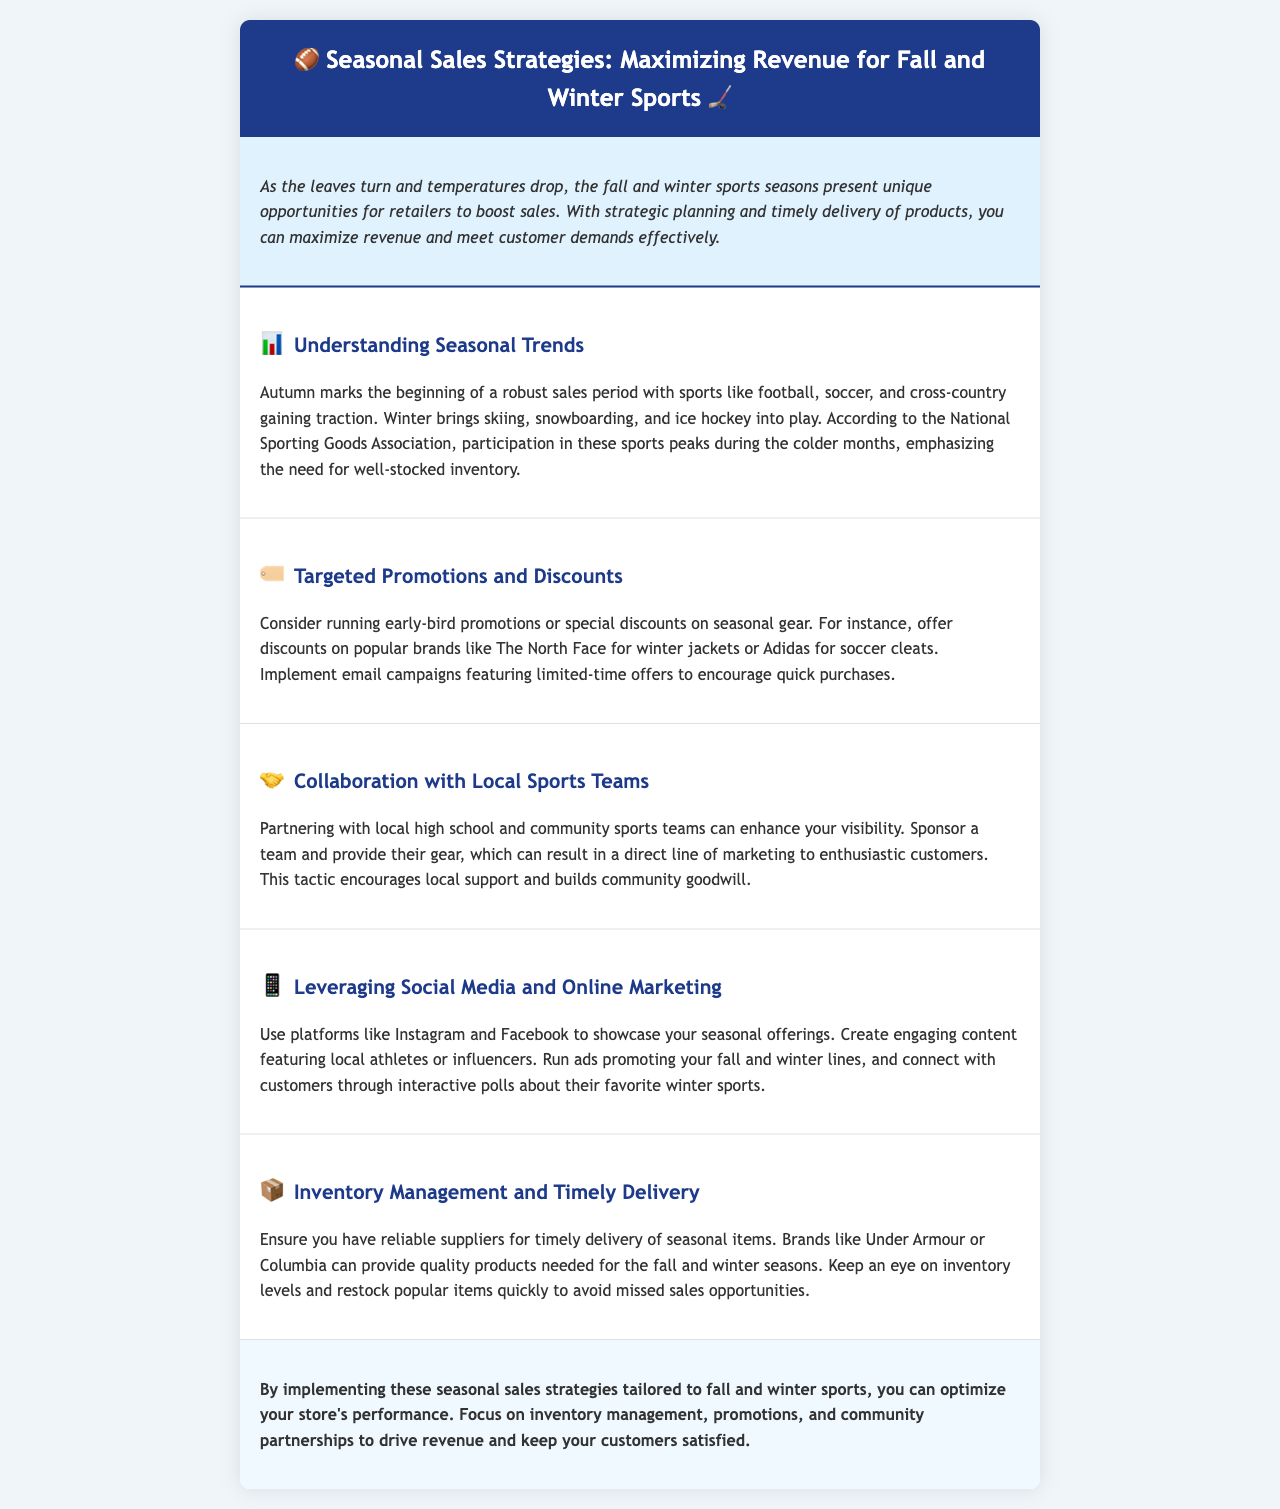what sports peak in participation during colder months? The document mentions that participation in sports like skiing, snowboarding, and ice hockey peaks during the colder months.
Answer: skiing, snowboarding, ice hockey which brands are suggested for discounts on winter jackets? The document suggests offering discounts on popular brands like The North Face for winter jackets.
Answer: The North Face what type of promotions are recommended for seasonal gear? The newsletter recommends running early-bird promotions or special discounts on seasonal gear.
Answer: early-bird promotions who can local stores collaborate with to enhance visibility? The document suggests partnering with local high school and community sports teams to enhance visibility.
Answer: local sports teams what social media platforms are mentioned for promoting seasonal offerings? The newsletter mentions using platforms like Instagram and Facebook for promoting seasonal offerings.
Answer: Instagram, Facebook how should stores handle inventory for fall and winter items? The document advises keeping an eye on inventory levels and restocking popular items quickly.
Answer: restock popular items quickly what is emphasized as a key element in maximizing revenue for fall and winter sports? Timely delivery of products is emphasized as a key element in maximizing revenue for fall and winter sports.
Answer: timely delivery what color is used for the header background? The document states that the header background color is #1e3a8a.
Answer: #1e3a8a 